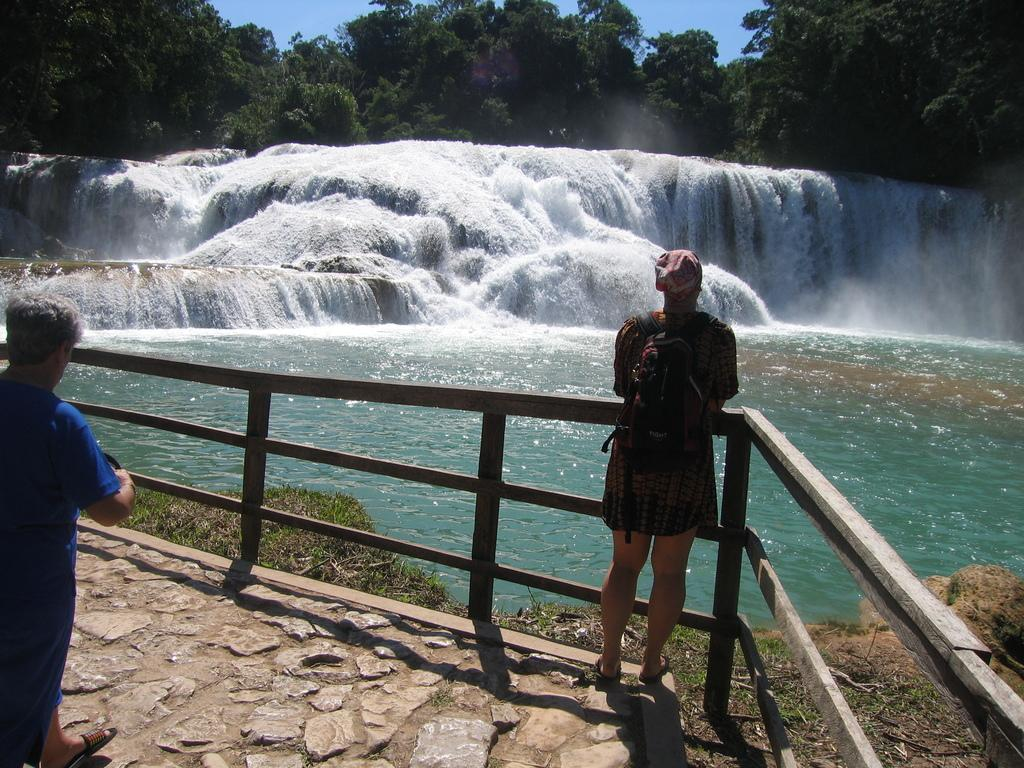How many people are in the image? There are two persons in the image. What is one person doing in relation to the railing? One person is standing near the railing. What can be seen in the background of the image? There are waterfalls, trees, and the sky visible in the background of the image. What type of trousers is the person wearing near the railing? There is no information about the person's trousers in the image, so we cannot determine the type of trousers they are wearing. Can you describe the tray that the person is holding near the railing? There is no tray present in the image; the person is simply standing near the railing. 